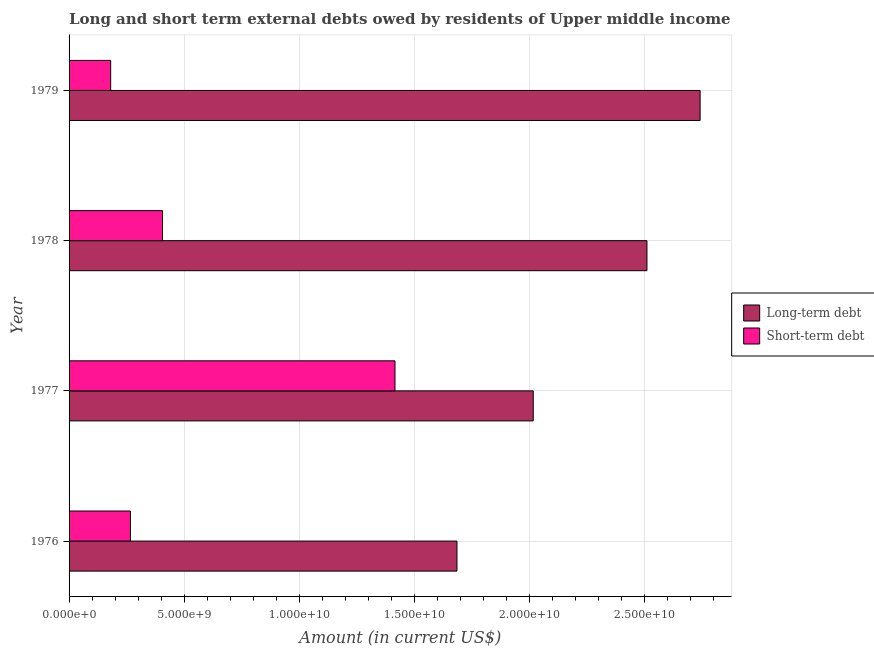How many different coloured bars are there?
Your answer should be very brief. 2. How many groups of bars are there?
Offer a very short reply. 4. How many bars are there on the 1st tick from the bottom?
Provide a succinct answer. 2. What is the label of the 3rd group of bars from the top?
Offer a terse response. 1977. What is the long-term debts owed by residents in 1978?
Keep it short and to the point. 2.51e+1. Across all years, what is the maximum short-term debts owed by residents?
Keep it short and to the point. 1.42e+1. Across all years, what is the minimum short-term debts owed by residents?
Your answer should be very brief. 1.81e+09. In which year was the long-term debts owed by residents maximum?
Keep it short and to the point. 1979. In which year was the short-term debts owed by residents minimum?
Give a very brief answer. 1979. What is the total short-term debts owed by residents in the graph?
Give a very brief answer. 2.27e+1. What is the difference between the long-term debts owed by residents in 1976 and that in 1978?
Keep it short and to the point. -8.26e+09. What is the difference between the short-term debts owed by residents in 1976 and the long-term debts owed by residents in 1977?
Offer a very short reply. -1.75e+1. What is the average short-term debts owed by residents per year?
Keep it short and to the point. 5.68e+09. In the year 1978, what is the difference between the long-term debts owed by residents and short-term debts owed by residents?
Provide a succinct answer. 2.11e+1. In how many years, is the short-term debts owed by residents greater than 4000000000 US$?
Provide a succinct answer. 2. What is the ratio of the short-term debts owed by residents in 1978 to that in 1979?
Your answer should be very brief. 2.25. Is the difference between the short-term debts owed by residents in 1976 and 1978 greater than the difference between the long-term debts owed by residents in 1976 and 1978?
Keep it short and to the point. Yes. What is the difference between the highest and the second highest long-term debts owed by residents?
Your response must be concise. 2.31e+09. What is the difference between the highest and the lowest long-term debts owed by residents?
Keep it short and to the point. 1.06e+1. Is the sum of the short-term debts owed by residents in 1976 and 1977 greater than the maximum long-term debts owed by residents across all years?
Give a very brief answer. No. What does the 1st bar from the top in 1978 represents?
Ensure brevity in your answer.  Short-term debt. What does the 2nd bar from the bottom in 1978 represents?
Give a very brief answer. Short-term debt. How many bars are there?
Offer a very short reply. 8. What is the difference between two consecutive major ticks on the X-axis?
Your answer should be compact. 5.00e+09. Are the values on the major ticks of X-axis written in scientific E-notation?
Your answer should be very brief. Yes. Does the graph contain any zero values?
Your response must be concise. No. Where does the legend appear in the graph?
Your answer should be compact. Center right. How many legend labels are there?
Your answer should be compact. 2. How are the legend labels stacked?
Your answer should be compact. Vertical. What is the title of the graph?
Keep it short and to the point. Long and short term external debts owed by residents of Upper middle income. What is the label or title of the X-axis?
Make the answer very short. Amount (in current US$). What is the Amount (in current US$) in Long-term debt in 1976?
Keep it short and to the point. 1.69e+1. What is the Amount (in current US$) in Short-term debt in 1976?
Provide a short and direct response. 2.67e+09. What is the Amount (in current US$) of Long-term debt in 1977?
Your answer should be compact. 2.02e+1. What is the Amount (in current US$) in Short-term debt in 1977?
Keep it short and to the point. 1.42e+1. What is the Amount (in current US$) in Long-term debt in 1978?
Your response must be concise. 2.51e+1. What is the Amount (in current US$) of Short-term debt in 1978?
Offer a very short reply. 4.06e+09. What is the Amount (in current US$) in Long-term debt in 1979?
Provide a short and direct response. 2.74e+1. What is the Amount (in current US$) of Short-term debt in 1979?
Make the answer very short. 1.81e+09. Across all years, what is the maximum Amount (in current US$) of Long-term debt?
Keep it short and to the point. 2.74e+1. Across all years, what is the maximum Amount (in current US$) of Short-term debt?
Your answer should be compact. 1.42e+1. Across all years, what is the minimum Amount (in current US$) in Long-term debt?
Your answer should be very brief. 1.69e+1. Across all years, what is the minimum Amount (in current US$) in Short-term debt?
Offer a terse response. 1.81e+09. What is the total Amount (in current US$) of Long-term debt in the graph?
Offer a very short reply. 8.96e+1. What is the total Amount (in current US$) of Short-term debt in the graph?
Provide a succinct answer. 2.27e+1. What is the difference between the Amount (in current US$) of Long-term debt in 1976 and that in 1977?
Offer a terse response. -3.31e+09. What is the difference between the Amount (in current US$) of Short-term debt in 1976 and that in 1977?
Keep it short and to the point. -1.15e+1. What is the difference between the Amount (in current US$) of Long-term debt in 1976 and that in 1978?
Offer a terse response. -8.26e+09. What is the difference between the Amount (in current US$) of Short-term debt in 1976 and that in 1978?
Provide a succinct answer. -1.39e+09. What is the difference between the Amount (in current US$) in Long-term debt in 1976 and that in 1979?
Offer a very short reply. -1.06e+1. What is the difference between the Amount (in current US$) of Short-term debt in 1976 and that in 1979?
Offer a very short reply. 8.61e+08. What is the difference between the Amount (in current US$) in Long-term debt in 1977 and that in 1978?
Provide a short and direct response. -4.94e+09. What is the difference between the Amount (in current US$) of Short-term debt in 1977 and that in 1978?
Provide a succinct answer. 1.01e+1. What is the difference between the Amount (in current US$) in Long-term debt in 1977 and that in 1979?
Keep it short and to the point. -7.25e+09. What is the difference between the Amount (in current US$) of Short-term debt in 1977 and that in 1979?
Your answer should be very brief. 1.24e+1. What is the difference between the Amount (in current US$) of Long-term debt in 1978 and that in 1979?
Give a very brief answer. -2.31e+09. What is the difference between the Amount (in current US$) in Short-term debt in 1978 and that in 1979?
Make the answer very short. 2.25e+09. What is the difference between the Amount (in current US$) in Long-term debt in 1976 and the Amount (in current US$) in Short-term debt in 1977?
Give a very brief answer. 2.69e+09. What is the difference between the Amount (in current US$) of Long-term debt in 1976 and the Amount (in current US$) of Short-term debt in 1978?
Give a very brief answer. 1.28e+1. What is the difference between the Amount (in current US$) in Long-term debt in 1976 and the Amount (in current US$) in Short-term debt in 1979?
Your answer should be compact. 1.50e+1. What is the difference between the Amount (in current US$) in Long-term debt in 1977 and the Amount (in current US$) in Short-term debt in 1978?
Give a very brief answer. 1.61e+1. What is the difference between the Amount (in current US$) in Long-term debt in 1977 and the Amount (in current US$) in Short-term debt in 1979?
Ensure brevity in your answer.  1.84e+1. What is the difference between the Amount (in current US$) of Long-term debt in 1978 and the Amount (in current US$) of Short-term debt in 1979?
Make the answer very short. 2.33e+1. What is the average Amount (in current US$) of Long-term debt per year?
Keep it short and to the point. 2.24e+1. What is the average Amount (in current US$) in Short-term debt per year?
Your answer should be compact. 5.68e+09. In the year 1976, what is the difference between the Amount (in current US$) of Long-term debt and Amount (in current US$) of Short-term debt?
Offer a very short reply. 1.42e+1. In the year 1977, what is the difference between the Amount (in current US$) of Long-term debt and Amount (in current US$) of Short-term debt?
Offer a very short reply. 6.01e+09. In the year 1978, what is the difference between the Amount (in current US$) in Long-term debt and Amount (in current US$) in Short-term debt?
Keep it short and to the point. 2.11e+1. In the year 1979, what is the difference between the Amount (in current US$) of Long-term debt and Amount (in current US$) of Short-term debt?
Provide a short and direct response. 2.56e+1. What is the ratio of the Amount (in current US$) in Long-term debt in 1976 to that in 1977?
Offer a terse response. 0.84. What is the ratio of the Amount (in current US$) of Short-term debt in 1976 to that in 1977?
Give a very brief answer. 0.19. What is the ratio of the Amount (in current US$) in Long-term debt in 1976 to that in 1978?
Make the answer very short. 0.67. What is the ratio of the Amount (in current US$) in Short-term debt in 1976 to that in 1978?
Your answer should be very brief. 0.66. What is the ratio of the Amount (in current US$) of Long-term debt in 1976 to that in 1979?
Provide a succinct answer. 0.61. What is the ratio of the Amount (in current US$) of Short-term debt in 1976 to that in 1979?
Keep it short and to the point. 1.48. What is the ratio of the Amount (in current US$) of Long-term debt in 1977 to that in 1978?
Your answer should be very brief. 0.8. What is the ratio of the Amount (in current US$) in Short-term debt in 1977 to that in 1978?
Offer a very short reply. 3.49. What is the ratio of the Amount (in current US$) of Long-term debt in 1977 to that in 1979?
Your response must be concise. 0.74. What is the ratio of the Amount (in current US$) in Short-term debt in 1977 to that in 1979?
Ensure brevity in your answer.  7.83. What is the ratio of the Amount (in current US$) in Long-term debt in 1978 to that in 1979?
Provide a succinct answer. 0.92. What is the ratio of the Amount (in current US$) of Short-term debt in 1978 to that in 1979?
Keep it short and to the point. 2.25. What is the difference between the highest and the second highest Amount (in current US$) of Long-term debt?
Your answer should be very brief. 2.31e+09. What is the difference between the highest and the second highest Amount (in current US$) in Short-term debt?
Your answer should be compact. 1.01e+1. What is the difference between the highest and the lowest Amount (in current US$) of Long-term debt?
Offer a terse response. 1.06e+1. What is the difference between the highest and the lowest Amount (in current US$) in Short-term debt?
Your answer should be compact. 1.24e+1. 